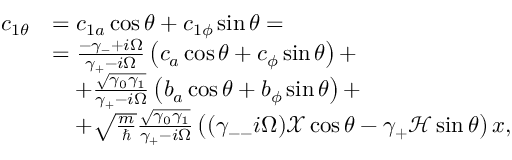<formula> <loc_0><loc_0><loc_500><loc_500>\begin{array} { r l } { c _ { 1 \theta } } & { = c _ { 1 a } \cos \theta + c _ { 1 \phi } \sin \theta = } \\ & { = \frac { - \gamma _ { - } + i \Omega } { \gamma _ { + } - i \Omega } \left ( c _ { a } \cos \theta + c _ { \phi } \sin \theta \right ) + } \\ & { \quad + \frac { \sqrt { \gamma _ { 0 } \gamma _ { 1 } } } { \gamma _ { + } - i \Omega } \left ( b _ { a } \cos \theta + b _ { \phi } \sin \theta \right ) + } \\ & { \quad + \sqrt { \frac { m } { } } \frac { \sqrt { \gamma _ { 0 } \gamma _ { 1 } } } { \gamma _ { + } - i \Omega } \left ( ( \gamma _ { - - } i \Omega ) \mathcal { X } \cos \theta - \gamma _ { + } \mathcal { H } \sin \theta \right ) x , } \end{array}</formula> 